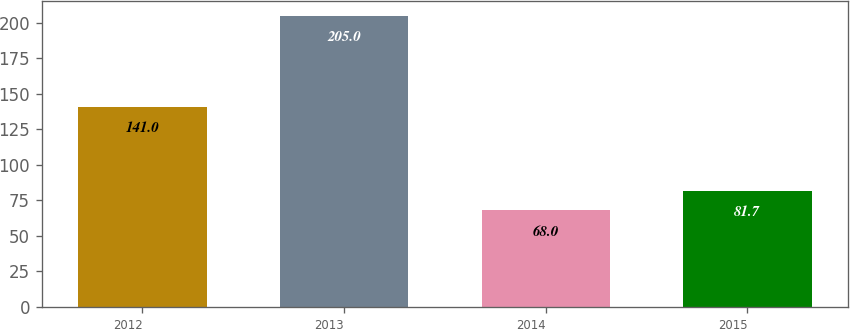<chart> <loc_0><loc_0><loc_500><loc_500><bar_chart><fcel>2012<fcel>2013<fcel>2014<fcel>2015<nl><fcel>141<fcel>205<fcel>68<fcel>81.7<nl></chart> 